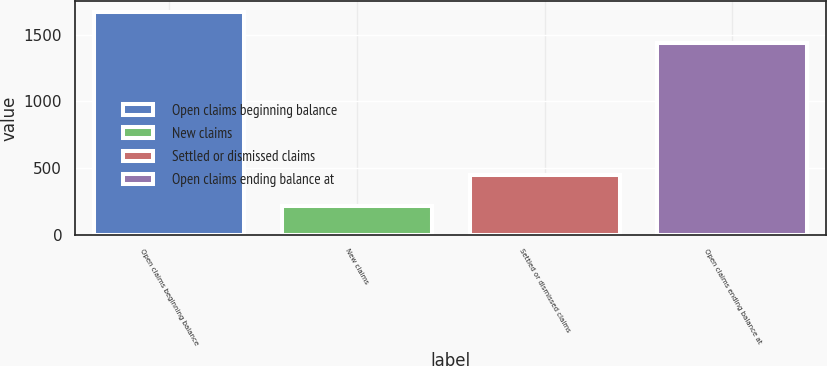<chart> <loc_0><loc_0><loc_500><loc_500><bar_chart><fcel>Open claims beginning balance<fcel>New claims<fcel>Settled or dismissed claims<fcel>Open claims ending balance at<nl><fcel>1670<fcel>216<fcel>449<fcel>1437<nl></chart> 